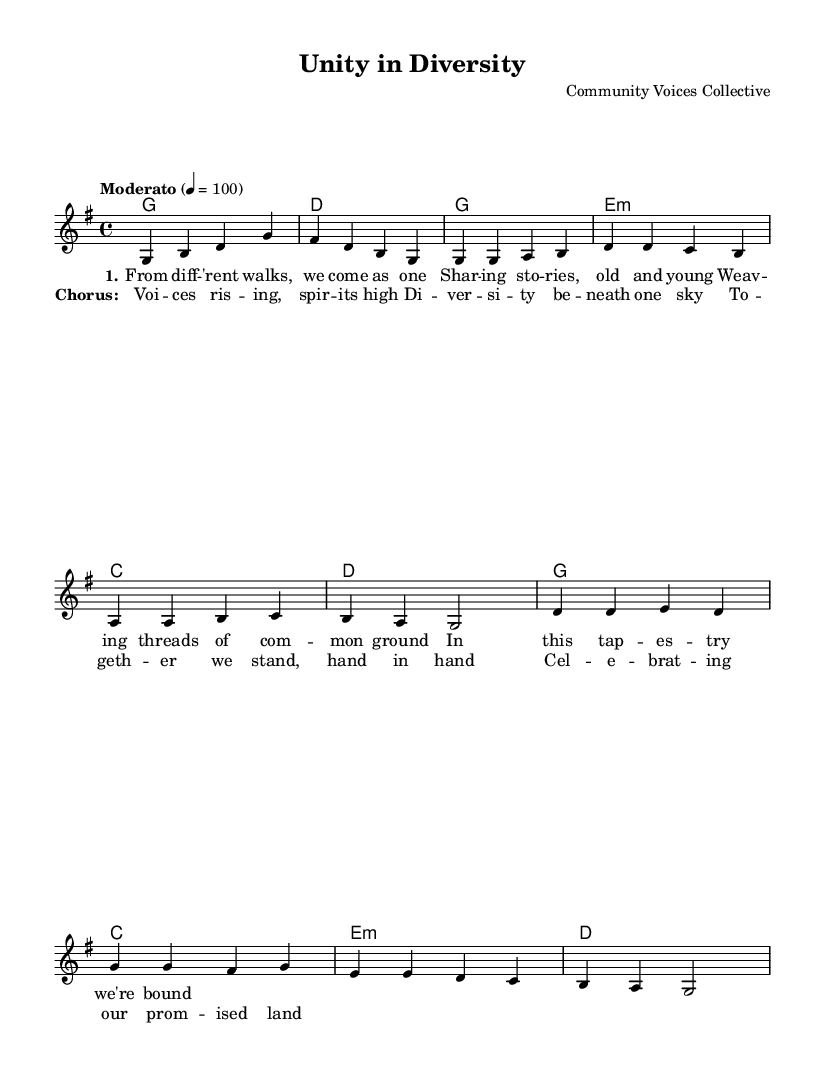What is the key signature of this music? The key signature is G major, which has one sharp. This can be determined by looking at the key indicated right at the beginning of the score.
Answer: G major What is the time signature of this music? The time signature is 4/4, visible at the start of the score, indicating that there are four beats in each measure, and the quarter note gets one beat.
Answer: 4/4 What is the tempo marking for this piece? The tempo marking is "Moderato" and states a metronome marking of 100 beats per minute. This is indicated at the beginning of the score, after the time signature.
Answer: Moderato How many verses are in the lyrics provided? There is one verse in the lyrics provided in the score. This can be confirmed by counting the section marked as "verseOne" which appears only once in the lyrics.
Answer: 1 What chords are used in the chorus? The chords in the chorus are G, C, E minor, and D, as visible in the chord mode section under the choral notation for the chorus. Each chord is aligned with the melody notes in the score.
Answer: G, C, E minor, D What is the central theme expressed in the lyrics? The central theme expressed in the lyrics is unity and diversity, reflecting on communal stories and celebration of diverse voices, as indicated in the content of the text.
Answer: Unity and diversity How many measures are there in the chorus section? There are four measures in the chorus section as it can be counted from the visual representation of the musical notation in that part of the score.
Answer: 4 